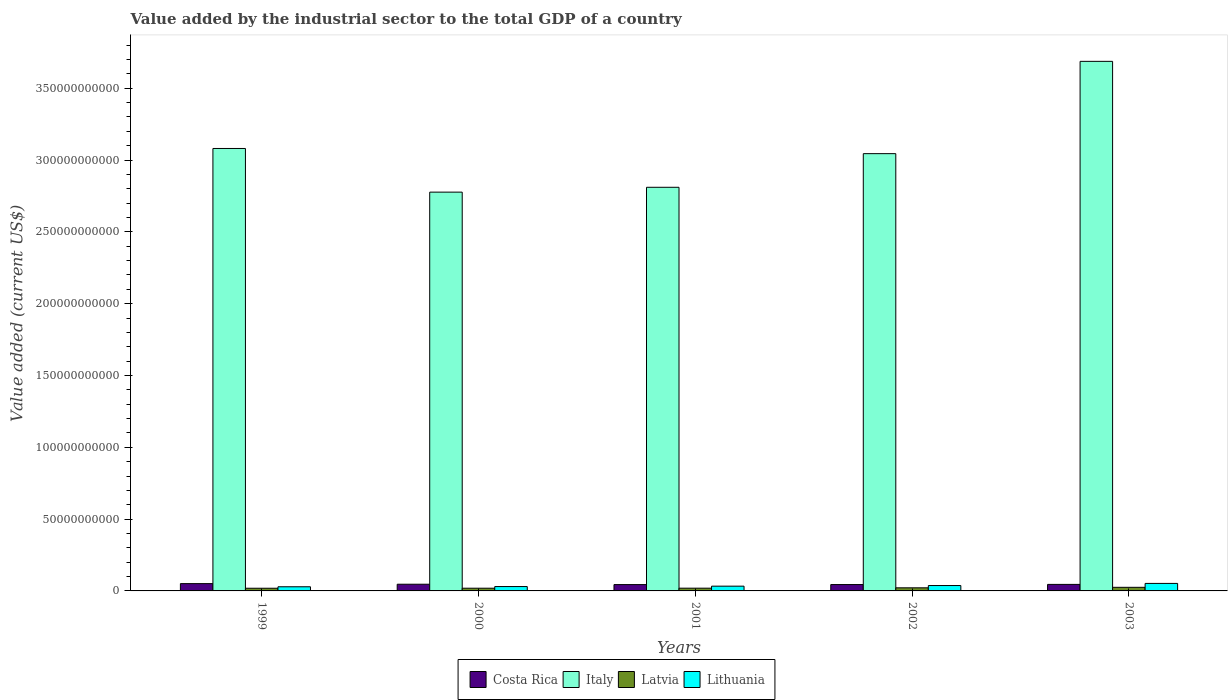How many different coloured bars are there?
Give a very brief answer. 4. Are the number of bars per tick equal to the number of legend labels?
Make the answer very short. Yes. Are the number of bars on each tick of the X-axis equal?
Offer a very short reply. Yes. What is the label of the 5th group of bars from the left?
Provide a short and direct response. 2003. In how many cases, is the number of bars for a given year not equal to the number of legend labels?
Your answer should be compact. 0. What is the value added by the industrial sector to the total GDP in Italy in 2003?
Offer a very short reply. 3.69e+11. Across all years, what is the maximum value added by the industrial sector to the total GDP in Italy?
Offer a terse response. 3.69e+11. Across all years, what is the minimum value added by the industrial sector to the total GDP in Costa Rica?
Provide a succinct answer. 4.41e+09. In which year was the value added by the industrial sector to the total GDP in Latvia maximum?
Make the answer very short. 2003. In which year was the value added by the industrial sector to the total GDP in Italy minimum?
Offer a terse response. 2000. What is the total value added by the industrial sector to the total GDP in Costa Rica in the graph?
Offer a terse response. 2.31e+1. What is the difference between the value added by the industrial sector to the total GDP in Italy in 2000 and that in 2003?
Offer a terse response. -9.11e+1. What is the difference between the value added by the industrial sector to the total GDP in Costa Rica in 2003 and the value added by the industrial sector to the total GDP in Latvia in 2001?
Your response must be concise. 2.64e+09. What is the average value added by the industrial sector to the total GDP in Latvia per year?
Ensure brevity in your answer.  2.07e+09. In the year 2003, what is the difference between the value added by the industrial sector to the total GDP in Costa Rica and value added by the industrial sector to the total GDP in Latvia?
Your response must be concise. 2.03e+09. What is the ratio of the value added by the industrial sector to the total GDP in Costa Rica in 1999 to that in 2003?
Your response must be concise. 1.12. Is the value added by the industrial sector to the total GDP in Lithuania in 1999 less than that in 2003?
Keep it short and to the point. Yes. What is the difference between the highest and the second highest value added by the industrial sector to the total GDP in Lithuania?
Offer a very short reply. 1.48e+09. What is the difference between the highest and the lowest value added by the industrial sector to the total GDP in Lithuania?
Your response must be concise. 2.35e+09. In how many years, is the value added by the industrial sector to the total GDP in Lithuania greater than the average value added by the industrial sector to the total GDP in Lithuania taken over all years?
Give a very brief answer. 2. Is the sum of the value added by the industrial sector to the total GDP in Latvia in 2002 and 2003 greater than the maximum value added by the industrial sector to the total GDP in Italy across all years?
Make the answer very short. No. Is it the case that in every year, the sum of the value added by the industrial sector to the total GDP in Italy and value added by the industrial sector to the total GDP in Lithuania is greater than the sum of value added by the industrial sector to the total GDP in Latvia and value added by the industrial sector to the total GDP in Costa Rica?
Provide a succinct answer. Yes. What does the 4th bar from the left in 2001 represents?
Ensure brevity in your answer.  Lithuania. How many bars are there?
Your response must be concise. 20. What is the difference between two consecutive major ticks on the Y-axis?
Keep it short and to the point. 5.00e+1. Does the graph contain any zero values?
Offer a terse response. No. Where does the legend appear in the graph?
Offer a terse response. Bottom center. How many legend labels are there?
Your response must be concise. 4. How are the legend labels stacked?
Your response must be concise. Horizontal. What is the title of the graph?
Provide a short and direct response. Value added by the industrial sector to the total GDP of a country. What is the label or title of the X-axis?
Provide a short and direct response. Years. What is the label or title of the Y-axis?
Make the answer very short. Value added (current US$). What is the Value added (current US$) of Costa Rica in 1999?
Give a very brief answer. 5.08e+09. What is the Value added (current US$) in Italy in 1999?
Give a very brief answer. 3.08e+11. What is the Value added (current US$) in Latvia in 1999?
Provide a short and direct response. 1.87e+09. What is the Value added (current US$) in Lithuania in 1999?
Give a very brief answer. 2.88e+09. What is the Value added (current US$) in Costa Rica in 2000?
Offer a very short reply. 4.66e+09. What is the Value added (current US$) of Italy in 2000?
Provide a succinct answer. 2.78e+11. What is the Value added (current US$) of Latvia in 2000?
Make the answer very short. 1.88e+09. What is the Value added (current US$) of Lithuania in 2000?
Give a very brief answer. 3.04e+09. What is the Value added (current US$) in Costa Rica in 2001?
Keep it short and to the point. 4.41e+09. What is the Value added (current US$) in Italy in 2001?
Offer a very short reply. 2.81e+11. What is the Value added (current US$) in Latvia in 2001?
Your answer should be compact. 1.91e+09. What is the Value added (current US$) in Lithuania in 2001?
Your answer should be very brief. 3.31e+09. What is the Value added (current US$) in Costa Rica in 2002?
Make the answer very short. 4.43e+09. What is the Value added (current US$) in Italy in 2002?
Ensure brevity in your answer.  3.04e+11. What is the Value added (current US$) of Latvia in 2002?
Provide a short and direct response. 2.16e+09. What is the Value added (current US$) of Lithuania in 2002?
Provide a short and direct response. 3.75e+09. What is the Value added (current US$) in Costa Rica in 2003?
Your answer should be very brief. 4.55e+09. What is the Value added (current US$) in Italy in 2003?
Provide a succinct answer. 3.69e+11. What is the Value added (current US$) of Latvia in 2003?
Keep it short and to the point. 2.51e+09. What is the Value added (current US$) in Lithuania in 2003?
Ensure brevity in your answer.  5.23e+09. Across all years, what is the maximum Value added (current US$) in Costa Rica?
Provide a short and direct response. 5.08e+09. Across all years, what is the maximum Value added (current US$) in Italy?
Your response must be concise. 3.69e+11. Across all years, what is the maximum Value added (current US$) in Latvia?
Ensure brevity in your answer.  2.51e+09. Across all years, what is the maximum Value added (current US$) of Lithuania?
Provide a short and direct response. 5.23e+09. Across all years, what is the minimum Value added (current US$) of Costa Rica?
Provide a short and direct response. 4.41e+09. Across all years, what is the minimum Value added (current US$) of Italy?
Your answer should be very brief. 2.78e+11. Across all years, what is the minimum Value added (current US$) of Latvia?
Make the answer very short. 1.87e+09. Across all years, what is the minimum Value added (current US$) of Lithuania?
Offer a very short reply. 2.88e+09. What is the total Value added (current US$) of Costa Rica in the graph?
Your answer should be compact. 2.31e+1. What is the total Value added (current US$) in Italy in the graph?
Ensure brevity in your answer.  1.54e+12. What is the total Value added (current US$) in Latvia in the graph?
Your answer should be compact. 1.03e+1. What is the total Value added (current US$) of Lithuania in the graph?
Offer a terse response. 1.82e+1. What is the difference between the Value added (current US$) in Costa Rica in 1999 and that in 2000?
Give a very brief answer. 4.26e+08. What is the difference between the Value added (current US$) in Italy in 1999 and that in 2000?
Keep it short and to the point. 3.04e+1. What is the difference between the Value added (current US$) in Latvia in 1999 and that in 2000?
Offer a very short reply. -1.54e+07. What is the difference between the Value added (current US$) of Lithuania in 1999 and that in 2000?
Ensure brevity in your answer.  -1.52e+08. What is the difference between the Value added (current US$) of Costa Rica in 1999 and that in 2001?
Offer a very short reply. 6.73e+08. What is the difference between the Value added (current US$) of Italy in 1999 and that in 2001?
Give a very brief answer. 2.70e+1. What is the difference between the Value added (current US$) of Latvia in 1999 and that in 2001?
Provide a short and direct response. -4.03e+07. What is the difference between the Value added (current US$) in Lithuania in 1999 and that in 2001?
Provide a succinct answer. -4.30e+08. What is the difference between the Value added (current US$) in Costa Rica in 1999 and that in 2002?
Provide a short and direct response. 6.53e+08. What is the difference between the Value added (current US$) of Italy in 1999 and that in 2002?
Offer a terse response. 3.60e+09. What is the difference between the Value added (current US$) in Latvia in 1999 and that in 2002?
Provide a short and direct response. -2.95e+08. What is the difference between the Value added (current US$) of Lithuania in 1999 and that in 2002?
Provide a succinct answer. -8.65e+08. What is the difference between the Value added (current US$) in Costa Rica in 1999 and that in 2003?
Keep it short and to the point. 5.37e+08. What is the difference between the Value added (current US$) in Italy in 1999 and that in 2003?
Give a very brief answer. -6.07e+1. What is the difference between the Value added (current US$) in Latvia in 1999 and that in 2003?
Ensure brevity in your answer.  -6.45e+08. What is the difference between the Value added (current US$) in Lithuania in 1999 and that in 2003?
Your answer should be very brief. -2.35e+09. What is the difference between the Value added (current US$) of Costa Rica in 2000 and that in 2001?
Offer a very short reply. 2.47e+08. What is the difference between the Value added (current US$) in Italy in 2000 and that in 2001?
Offer a terse response. -3.37e+09. What is the difference between the Value added (current US$) in Latvia in 2000 and that in 2001?
Your response must be concise. -2.49e+07. What is the difference between the Value added (current US$) in Lithuania in 2000 and that in 2001?
Provide a succinct answer. -2.78e+08. What is the difference between the Value added (current US$) in Costa Rica in 2000 and that in 2002?
Ensure brevity in your answer.  2.27e+08. What is the difference between the Value added (current US$) in Italy in 2000 and that in 2002?
Your response must be concise. -2.68e+1. What is the difference between the Value added (current US$) in Latvia in 2000 and that in 2002?
Provide a succinct answer. -2.80e+08. What is the difference between the Value added (current US$) in Lithuania in 2000 and that in 2002?
Provide a succinct answer. -7.13e+08. What is the difference between the Value added (current US$) of Costa Rica in 2000 and that in 2003?
Ensure brevity in your answer.  1.11e+08. What is the difference between the Value added (current US$) of Italy in 2000 and that in 2003?
Keep it short and to the point. -9.11e+1. What is the difference between the Value added (current US$) of Latvia in 2000 and that in 2003?
Offer a very short reply. -6.29e+08. What is the difference between the Value added (current US$) of Lithuania in 2000 and that in 2003?
Your response must be concise. -2.20e+09. What is the difference between the Value added (current US$) of Costa Rica in 2001 and that in 2002?
Your answer should be very brief. -1.97e+07. What is the difference between the Value added (current US$) in Italy in 2001 and that in 2002?
Ensure brevity in your answer.  -2.34e+1. What is the difference between the Value added (current US$) in Latvia in 2001 and that in 2002?
Your answer should be compact. -2.55e+08. What is the difference between the Value added (current US$) in Lithuania in 2001 and that in 2002?
Your answer should be compact. -4.34e+08. What is the difference between the Value added (current US$) in Costa Rica in 2001 and that in 2003?
Your response must be concise. -1.36e+08. What is the difference between the Value added (current US$) in Italy in 2001 and that in 2003?
Your answer should be very brief. -8.77e+1. What is the difference between the Value added (current US$) of Latvia in 2001 and that in 2003?
Offer a terse response. -6.04e+08. What is the difference between the Value added (current US$) of Lithuania in 2001 and that in 2003?
Your answer should be very brief. -1.92e+09. What is the difference between the Value added (current US$) in Costa Rica in 2002 and that in 2003?
Your answer should be compact. -1.17e+08. What is the difference between the Value added (current US$) in Italy in 2002 and that in 2003?
Keep it short and to the point. -6.43e+1. What is the difference between the Value added (current US$) in Latvia in 2002 and that in 2003?
Provide a short and direct response. -3.50e+08. What is the difference between the Value added (current US$) in Lithuania in 2002 and that in 2003?
Make the answer very short. -1.48e+09. What is the difference between the Value added (current US$) in Costa Rica in 1999 and the Value added (current US$) in Italy in 2000?
Offer a very short reply. -2.73e+11. What is the difference between the Value added (current US$) of Costa Rica in 1999 and the Value added (current US$) of Latvia in 2000?
Your answer should be compact. 3.20e+09. What is the difference between the Value added (current US$) of Costa Rica in 1999 and the Value added (current US$) of Lithuania in 2000?
Offer a very short reply. 2.05e+09. What is the difference between the Value added (current US$) of Italy in 1999 and the Value added (current US$) of Latvia in 2000?
Offer a terse response. 3.06e+11. What is the difference between the Value added (current US$) of Italy in 1999 and the Value added (current US$) of Lithuania in 2000?
Give a very brief answer. 3.05e+11. What is the difference between the Value added (current US$) of Latvia in 1999 and the Value added (current US$) of Lithuania in 2000?
Keep it short and to the point. -1.17e+09. What is the difference between the Value added (current US$) in Costa Rica in 1999 and the Value added (current US$) in Italy in 2001?
Make the answer very short. -2.76e+11. What is the difference between the Value added (current US$) in Costa Rica in 1999 and the Value added (current US$) in Latvia in 2001?
Provide a succinct answer. 3.18e+09. What is the difference between the Value added (current US$) in Costa Rica in 1999 and the Value added (current US$) in Lithuania in 2001?
Give a very brief answer. 1.77e+09. What is the difference between the Value added (current US$) in Italy in 1999 and the Value added (current US$) in Latvia in 2001?
Ensure brevity in your answer.  3.06e+11. What is the difference between the Value added (current US$) of Italy in 1999 and the Value added (current US$) of Lithuania in 2001?
Provide a short and direct response. 3.05e+11. What is the difference between the Value added (current US$) of Latvia in 1999 and the Value added (current US$) of Lithuania in 2001?
Give a very brief answer. -1.45e+09. What is the difference between the Value added (current US$) of Costa Rica in 1999 and the Value added (current US$) of Italy in 2002?
Provide a short and direct response. -2.99e+11. What is the difference between the Value added (current US$) of Costa Rica in 1999 and the Value added (current US$) of Latvia in 2002?
Provide a short and direct response. 2.92e+09. What is the difference between the Value added (current US$) in Costa Rica in 1999 and the Value added (current US$) in Lithuania in 2002?
Give a very brief answer. 1.34e+09. What is the difference between the Value added (current US$) of Italy in 1999 and the Value added (current US$) of Latvia in 2002?
Ensure brevity in your answer.  3.06e+11. What is the difference between the Value added (current US$) in Italy in 1999 and the Value added (current US$) in Lithuania in 2002?
Your response must be concise. 3.04e+11. What is the difference between the Value added (current US$) of Latvia in 1999 and the Value added (current US$) of Lithuania in 2002?
Make the answer very short. -1.88e+09. What is the difference between the Value added (current US$) in Costa Rica in 1999 and the Value added (current US$) in Italy in 2003?
Offer a terse response. -3.64e+11. What is the difference between the Value added (current US$) of Costa Rica in 1999 and the Value added (current US$) of Latvia in 2003?
Offer a very short reply. 2.57e+09. What is the difference between the Value added (current US$) of Costa Rica in 1999 and the Value added (current US$) of Lithuania in 2003?
Your answer should be very brief. -1.49e+08. What is the difference between the Value added (current US$) of Italy in 1999 and the Value added (current US$) of Latvia in 2003?
Provide a succinct answer. 3.06e+11. What is the difference between the Value added (current US$) in Italy in 1999 and the Value added (current US$) in Lithuania in 2003?
Ensure brevity in your answer.  3.03e+11. What is the difference between the Value added (current US$) in Latvia in 1999 and the Value added (current US$) in Lithuania in 2003?
Your response must be concise. -3.36e+09. What is the difference between the Value added (current US$) in Costa Rica in 2000 and the Value added (current US$) in Italy in 2001?
Offer a terse response. -2.76e+11. What is the difference between the Value added (current US$) in Costa Rica in 2000 and the Value added (current US$) in Latvia in 2001?
Offer a terse response. 2.75e+09. What is the difference between the Value added (current US$) in Costa Rica in 2000 and the Value added (current US$) in Lithuania in 2001?
Your answer should be compact. 1.34e+09. What is the difference between the Value added (current US$) in Italy in 2000 and the Value added (current US$) in Latvia in 2001?
Your answer should be compact. 2.76e+11. What is the difference between the Value added (current US$) of Italy in 2000 and the Value added (current US$) of Lithuania in 2001?
Your response must be concise. 2.74e+11. What is the difference between the Value added (current US$) of Latvia in 2000 and the Value added (current US$) of Lithuania in 2001?
Keep it short and to the point. -1.43e+09. What is the difference between the Value added (current US$) of Costa Rica in 2000 and the Value added (current US$) of Italy in 2002?
Make the answer very short. -3.00e+11. What is the difference between the Value added (current US$) in Costa Rica in 2000 and the Value added (current US$) in Latvia in 2002?
Offer a terse response. 2.49e+09. What is the difference between the Value added (current US$) of Costa Rica in 2000 and the Value added (current US$) of Lithuania in 2002?
Give a very brief answer. 9.09e+08. What is the difference between the Value added (current US$) in Italy in 2000 and the Value added (current US$) in Latvia in 2002?
Your response must be concise. 2.76e+11. What is the difference between the Value added (current US$) in Italy in 2000 and the Value added (current US$) in Lithuania in 2002?
Your response must be concise. 2.74e+11. What is the difference between the Value added (current US$) of Latvia in 2000 and the Value added (current US$) of Lithuania in 2002?
Give a very brief answer. -1.86e+09. What is the difference between the Value added (current US$) of Costa Rica in 2000 and the Value added (current US$) of Italy in 2003?
Offer a terse response. -3.64e+11. What is the difference between the Value added (current US$) of Costa Rica in 2000 and the Value added (current US$) of Latvia in 2003?
Provide a succinct answer. 2.14e+09. What is the difference between the Value added (current US$) of Costa Rica in 2000 and the Value added (current US$) of Lithuania in 2003?
Give a very brief answer. -5.75e+08. What is the difference between the Value added (current US$) in Italy in 2000 and the Value added (current US$) in Latvia in 2003?
Your answer should be very brief. 2.75e+11. What is the difference between the Value added (current US$) of Italy in 2000 and the Value added (current US$) of Lithuania in 2003?
Offer a very short reply. 2.72e+11. What is the difference between the Value added (current US$) of Latvia in 2000 and the Value added (current US$) of Lithuania in 2003?
Your answer should be compact. -3.35e+09. What is the difference between the Value added (current US$) of Costa Rica in 2001 and the Value added (current US$) of Italy in 2002?
Your answer should be very brief. -3.00e+11. What is the difference between the Value added (current US$) of Costa Rica in 2001 and the Value added (current US$) of Latvia in 2002?
Ensure brevity in your answer.  2.25e+09. What is the difference between the Value added (current US$) of Costa Rica in 2001 and the Value added (current US$) of Lithuania in 2002?
Give a very brief answer. 6.63e+08. What is the difference between the Value added (current US$) of Italy in 2001 and the Value added (current US$) of Latvia in 2002?
Your answer should be compact. 2.79e+11. What is the difference between the Value added (current US$) of Italy in 2001 and the Value added (current US$) of Lithuania in 2002?
Your response must be concise. 2.77e+11. What is the difference between the Value added (current US$) of Latvia in 2001 and the Value added (current US$) of Lithuania in 2002?
Ensure brevity in your answer.  -1.84e+09. What is the difference between the Value added (current US$) in Costa Rica in 2001 and the Value added (current US$) in Italy in 2003?
Make the answer very short. -3.64e+11. What is the difference between the Value added (current US$) in Costa Rica in 2001 and the Value added (current US$) in Latvia in 2003?
Provide a succinct answer. 1.90e+09. What is the difference between the Value added (current US$) in Costa Rica in 2001 and the Value added (current US$) in Lithuania in 2003?
Ensure brevity in your answer.  -8.22e+08. What is the difference between the Value added (current US$) of Italy in 2001 and the Value added (current US$) of Latvia in 2003?
Give a very brief answer. 2.79e+11. What is the difference between the Value added (current US$) of Italy in 2001 and the Value added (current US$) of Lithuania in 2003?
Offer a terse response. 2.76e+11. What is the difference between the Value added (current US$) of Latvia in 2001 and the Value added (current US$) of Lithuania in 2003?
Provide a succinct answer. -3.32e+09. What is the difference between the Value added (current US$) in Costa Rica in 2002 and the Value added (current US$) in Italy in 2003?
Provide a succinct answer. -3.64e+11. What is the difference between the Value added (current US$) in Costa Rica in 2002 and the Value added (current US$) in Latvia in 2003?
Your response must be concise. 1.92e+09. What is the difference between the Value added (current US$) of Costa Rica in 2002 and the Value added (current US$) of Lithuania in 2003?
Provide a succinct answer. -8.02e+08. What is the difference between the Value added (current US$) in Italy in 2002 and the Value added (current US$) in Latvia in 2003?
Provide a succinct answer. 3.02e+11. What is the difference between the Value added (current US$) of Italy in 2002 and the Value added (current US$) of Lithuania in 2003?
Ensure brevity in your answer.  2.99e+11. What is the difference between the Value added (current US$) in Latvia in 2002 and the Value added (current US$) in Lithuania in 2003?
Keep it short and to the point. -3.07e+09. What is the average Value added (current US$) in Costa Rica per year?
Provide a short and direct response. 4.63e+09. What is the average Value added (current US$) of Italy per year?
Offer a terse response. 3.08e+11. What is the average Value added (current US$) of Latvia per year?
Ensure brevity in your answer.  2.07e+09. What is the average Value added (current US$) in Lithuania per year?
Offer a terse response. 3.64e+09. In the year 1999, what is the difference between the Value added (current US$) of Costa Rica and Value added (current US$) of Italy?
Provide a succinct answer. -3.03e+11. In the year 1999, what is the difference between the Value added (current US$) in Costa Rica and Value added (current US$) in Latvia?
Ensure brevity in your answer.  3.22e+09. In the year 1999, what is the difference between the Value added (current US$) in Costa Rica and Value added (current US$) in Lithuania?
Make the answer very short. 2.20e+09. In the year 1999, what is the difference between the Value added (current US$) of Italy and Value added (current US$) of Latvia?
Your response must be concise. 3.06e+11. In the year 1999, what is the difference between the Value added (current US$) in Italy and Value added (current US$) in Lithuania?
Your answer should be compact. 3.05e+11. In the year 1999, what is the difference between the Value added (current US$) of Latvia and Value added (current US$) of Lithuania?
Ensure brevity in your answer.  -1.02e+09. In the year 2000, what is the difference between the Value added (current US$) in Costa Rica and Value added (current US$) in Italy?
Ensure brevity in your answer.  -2.73e+11. In the year 2000, what is the difference between the Value added (current US$) of Costa Rica and Value added (current US$) of Latvia?
Ensure brevity in your answer.  2.77e+09. In the year 2000, what is the difference between the Value added (current US$) in Costa Rica and Value added (current US$) in Lithuania?
Your response must be concise. 1.62e+09. In the year 2000, what is the difference between the Value added (current US$) in Italy and Value added (current US$) in Latvia?
Your response must be concise. 2.76e+11. In the year 2000, what is the difference between the Value added (current US$) of Italy and Value added (current US$) of Lithuania?
Your answer should be very brief. 2.75e+11. In the year 2000, what is the difference between the Value added (current US$) of Latvia and Value added (current US$) of Lithuania?
Your answer should be very brief. -1.15e+09. In the year 2001, what is the difference between the Value added (current US$) of Costa Rica and Value added (current US$) of Italy?
Offer a very short reply. -2.77e+11. In the year 2001, what is the difference between the Value added (current US$) in Costa Rica and Value added (current US$) in Latvia?
Your response must be concise. 2.50e+09. In the year 2001, what is the difference between the Value added (current US$) of Costa Rica and Value added (current US$) of Lithuania?
Your answer should be compact. 1.10e+09. In the year 2001, what is the difference between the Value added (current US$) of Italy and Value added (current US$) of Latvia?
Keep it short and to the point. 2.79e+11. In the year 2001, what is the difference between the Value added (current US$) in Italy and Value added (current US$) in Lithuania?
Your response must be concise. 2.78e+11. In the year 2001, what is the difference between the Value added (current US$) in Latvia and Value added (current US$) in Lithuania?
Provide a short and direct response. -1.41e+09. In the year 2002, what is the difference between the Value added (current US$) of Costa Rica and Value added (current US$) of Italy?
Ensure brevity in your answer.  -3.00e+11. In the year 2002, what is the difference between the Value added (current US$) in Costa Rica and Value added (current US$) in Latvia?
Make the answer very short. 2.27e+09. In the year 2002, what is the difference between the Value added (current US$) in Costa Rica and Value added (current US$) in Lithuania?
Offer a terse response. 6.82e+08. In the year 2002, what is the difference between the Value added (current US$) in Italy and Value added (current US$) in Latvia?
Keep it short and to the point. 3.02e+11. In the year 2002, what is the difference between the Value added (current US$) of Italy and Value added (current US$) of Lithuania?
Your answer should be very brief. 3.01e+11. In the year 2002, what is the difference between the Value added (current US$) in Latvia and Value added (current US$) in Lithuania?
Your answer should be very brief. -1.58e+09. In the year 2003, what is the difference between the Value added (current US$) of Costa Rica and Value added (current US$) of Italy?
Your response must be concise. -3.64e+11. In the year 2003, what is the difference between the Value added (current US$) in Costa Rica and Value added (current US$) in Latvia?
Provide a succinct answer. 2.03e+09. In the year 2003, what is the difference between the Value added (current US$) in Costa Rica and Value added (current US$) in Lithuania?
Your answer should be compact. -6.85e+08. In the year 2003, what is the difference between the Value added (current US$) in Italy and Value added (current US$) in Latvia?
Provide a succinct answer. 3.66e+11. In the year 2003, what is the difference between the Value added (current US$) in Italy and Value added (current US$) in Lithuania?
Your answer should be very brief. 3.63e+11. In the year 2003, what is the difference between the Value added (current US$) of Latvia and Value added (current US$) of Lithuania?
Keep it short and to the point. -2.72e+09. What is the ratio of the Value added (current US$) of Costa Rica in 1999 to that in 2000?
Offer a very short reply. 1.09. What is the ratio of the Value added (current US$) in Italy in 1999 to that in 2000?
Your answer should be compact. 1.11. What is the ratio of the Value added (current US$) in Latvia in 1999 to that in 2000?
Offer a terse response. 0.99. What is the ratio of the Value added (current US$) of Lithuania in 1999 to that in 2000?
Your answer should be very brief. 0.95. What is the ratio of the Value added (current US$) of Costa Rica in 1999 to that in 2001?
Offer a very short reply. 1.15. What is the ratio of the Value added (current US$) in Italy in 1999 to that in 2001?
Give a very brief answer. 1.1. What is the ratio of the Value added (current US$) of Latvia in 1999 to that in 2001?
Make the answer very short. 0.98. What is the ratio of the Value added (current US$) of Lithuania in 1999 to that in 2001?
Provide a short and direct response. 0.87. What is the ratio of the Value added (current US$) in Costa Rica in 1999 to that in 2002?
Offer a terse response. 1.15. What is the ratio of the Value added (current US$) of Italy in 1999 to that in 2002?
Offer a very short reply. 1.01. What is the ratio of the Value added (current US$) in Latvia in 1999 to that in 2002?
Provide a succinct answer. 0.86. What is the ratio of the Value added (current US$) in Lithuania in 1999 to that in 2002?
Your answer should be very brief. 0.77. What is the ratio of the Value added (current US$) of Costa Rica in 1999 to that in 2003?
Your response must be concise. 1.12. What is the ratio of the Value added (current US$) in Italy in 1999 to that in 2003?
Your answer should be very brief. 0.84. What is the ratio of the Value added (current US$) in Latvia in 1999 to that in 2003?
Your response must be concise. 0.74. What is the ratio of the Value added (current US$) of Lithuania in 1999 to that in 2003?
Provide a short and direct response. 0.55. What is the ratio of the Value added (current US$) in Costa Rica in 2000 to that in 2001?
Ensure brevity in your answer.  1.06. What is the ratio of the Value added (current US$) of Latvia in 2000 to that in 2001?
Your response must be concise. 0.99. What is the ratio of the Value added (current US$) of Lithuania in 2000 to that in 2001?
Provide a succinct answer. 0.92. What is the ratio of the Value added (current US$) of Costa Rica in 2000 to that in 2002?
Your response must be concise. 1.05. What is the ratio of the Value added (current US$) of Italy in 2000 to that in 2002?
Keep it short and to the point. 0.91. What is the ratio of the Value added (current US$) in Latvia in 2000 to that in 2002?
Make the answer very short. 0.87. What is the ratio of the Value added (current US$) in Lithuania in 2000 to that in 2002?
Offer a terse response. 0.81. What is the ratio of the Value added (current US$) in Costa Rica in 2000 to that in 2003?
Ensure brevity in your answer.  1.02. What is the ratio of the Value added (current US$) in Italy in 2000 to that in 2003?
Make the answer very short. 0.75. What is the ratio of the Value added (current US$) in Latvia in 2000 to that in 2003?
Make the answer very short. 0.75. What is the ratio of the Value added (current US$) of Lithuania in 2000 to that in 2003?
Give a very brief answer. 0.58. What is the ratio of the Value added (current US$) of Costa Rica in 2001 to that in 2002?
Provide a short and direct response. 1. What is the ratio of the Value added (current US$) in Italy in 2001 to that in 2002?
Make the answer very short. 0.92. What is the ratio of the Value added (current US$) of Latvia in 2001 to that in 2002?
Your answer should be compact. 0.88. What is the ratio of the Value added (current US$) of Lithuania in 2001 to that in 2002?
Offer a very short reply. 0.88. What is the ratio of the Value added (current US$) of Costa Rica in 2001 to that in 2003?
Ensure brevity in your answer.  0.97. What is the ratio of the Value added (current US$) in Italy in 2001 to that in 2003?
Provide a succinct answer. 0.76. What is the ratio of the Value added (current US$) of Latvia in 2001 to that in 2003?
Your answer should be very brief. 0.76. What is the ratio of the Value added (current US$) in Lithuania in 2001 to that in 2003?
Ensure brevity in your answer.  0.63. What is the ratio of the Value added (current US$) of Costa Rica in 2002 to that in 2003?
Ensure brevity in your answer.  0.97. What is the ratio of the Value added (current US$) in Italy in 2002 to that in 2003?
Offer a very short reply. 0.83. What is the ratio of the Value added (current US$) of Latvia in 2002 to that in 2003?
Your response must be concise. 0.86. What is the ratio of the Value added (current US$) in Lithuania in 2002 to that in 2003?
Give a very brief answer. 0.72. What is the difference between the highest and the second highest Value added (current US$) in Costa Rica?
Offer a very short reply. 4.26e+08. What is the difference between the highest and the second highest Value added (current US$) of Italy?
Your response must be concise. 6.07e+1. What is the difference between the highest and the second highest Value added (current US$) of Latvia?
Give a very brief answer. 3.50e+08. What is the difference between the highest and the second highest Value added (current US$) in Lithuania?
Make the answer very short. 1.48e+09. What is the difference between the highest and the lowest Value added (current US$) in Costa Rica?
Make the answer very short. 6.73e+08. What is the difference between the highest and the lowest Value added (current US$) in Italy?
Make the answer very short. 9.11e+1. What is the difference between the highest and the lowest Value added (current US$) in Latvia?
Offer a very short reply. 6.45e+08. What is the difference between the highest and the lowest Value added (current US$) in Lithuania?
Your response must be concise. 2.35e+09. 